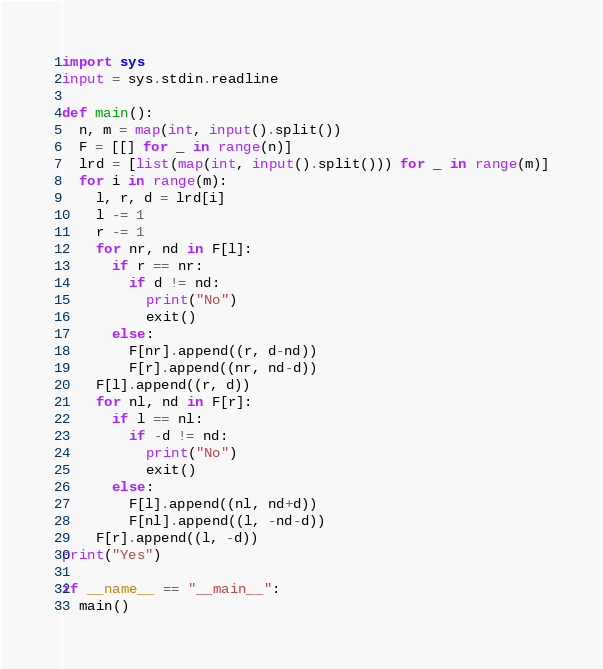<code> <loc_0><loc_0><loc_500><loc_500><_Python_>import sys
input = sys.stdin.readline

def main():
  n, m = map(int, input().split())
  F = [[] for _ in range(n)]
  lrd = [list(map(int, input().split())) for _ in range(m)]
  for i in range(m):
    l, r, d = lrd[i]
    l -= 1
    r -= 1
    for nr, nd in F[l]:
      if r == nr:
        if d != nd:
          print("No")
          exit()
      else:
        F[nr].append((r, d-nd))
        F[r].append((nr, nd-d))
    F[l].append((r, d))
    for nl, nd in F[r]:
      if l == nl:
        if -d != nd:
          print("No")
          exit()
      else:
        F[l].append((nl, nd+d))
        F[nl].append((l, -nd-d))
    F[r].append((l, -d))
print("Yes")
  
if __name__ == "__main__":
  main()</code> 